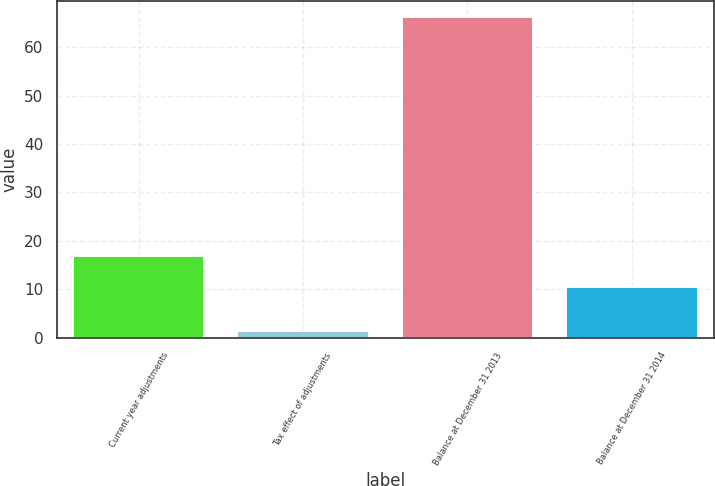<chart> <loc_0><loc_0><loc_500><loc_500><bar_chart><fcel>Current year adjustments<fcel>Tax effect of adjustments<fcel>Balance at December 31 2013<fcel>Balance at December 31 2014<nl><fcel>16.97<fcel>1.5<fcel>66.2<fcel>10.5<nl></chart> 